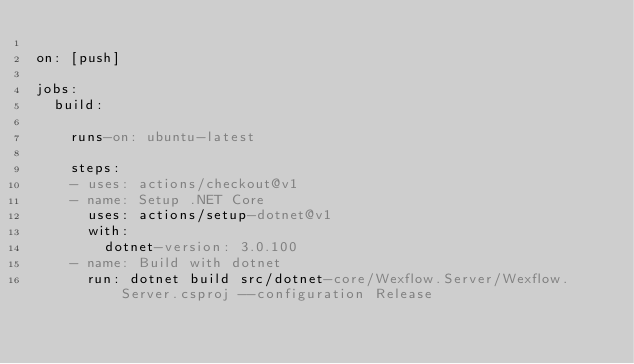Convert code to text. <code><loc_0><loc_0><loc_500><loc_500><_YAML_>
on: [push]

jobs:
  build:

    runs-on: ubuntu-latest

    steps:
    - uses: actions/checkout@v1
    - name: Setup .NET Core
      uses: actions/setup-dotnet@v1
      with:
        dotnet-version: 3.0.100
    - name: Build with dotnet
      run: dotnet build src/dotnet-core/Wexflow.Server/Wexflow.Server.csproj --configuration Release
</code> 